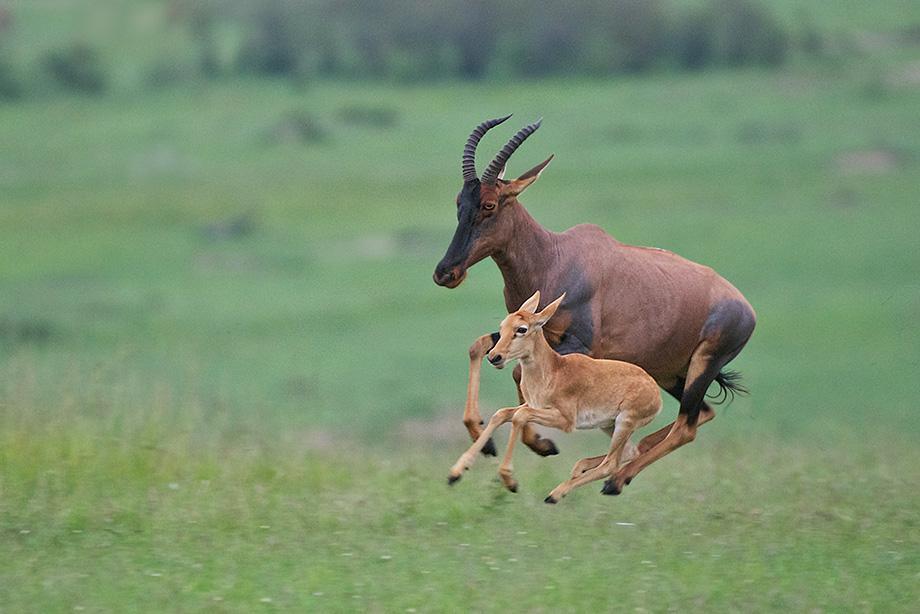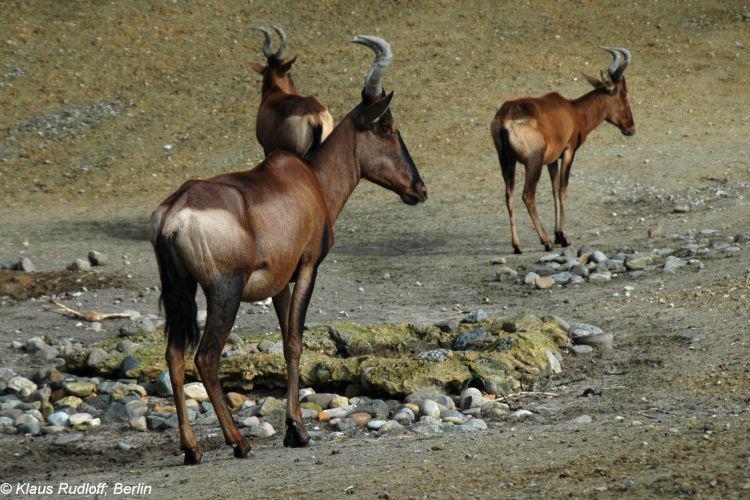The first image is the image on the left, the second image is the image on the right. Given the left and right images, does the statement "The right image contains at least three hartebeest's." hold true? Answer yes or no. Yes. The first image is the image on the left, the second image is the image on the right. Analyze the images presented: Is the assertion "All hooved animals in one image have both front legs off the ground." valid? Answer yes or no. Yes. 